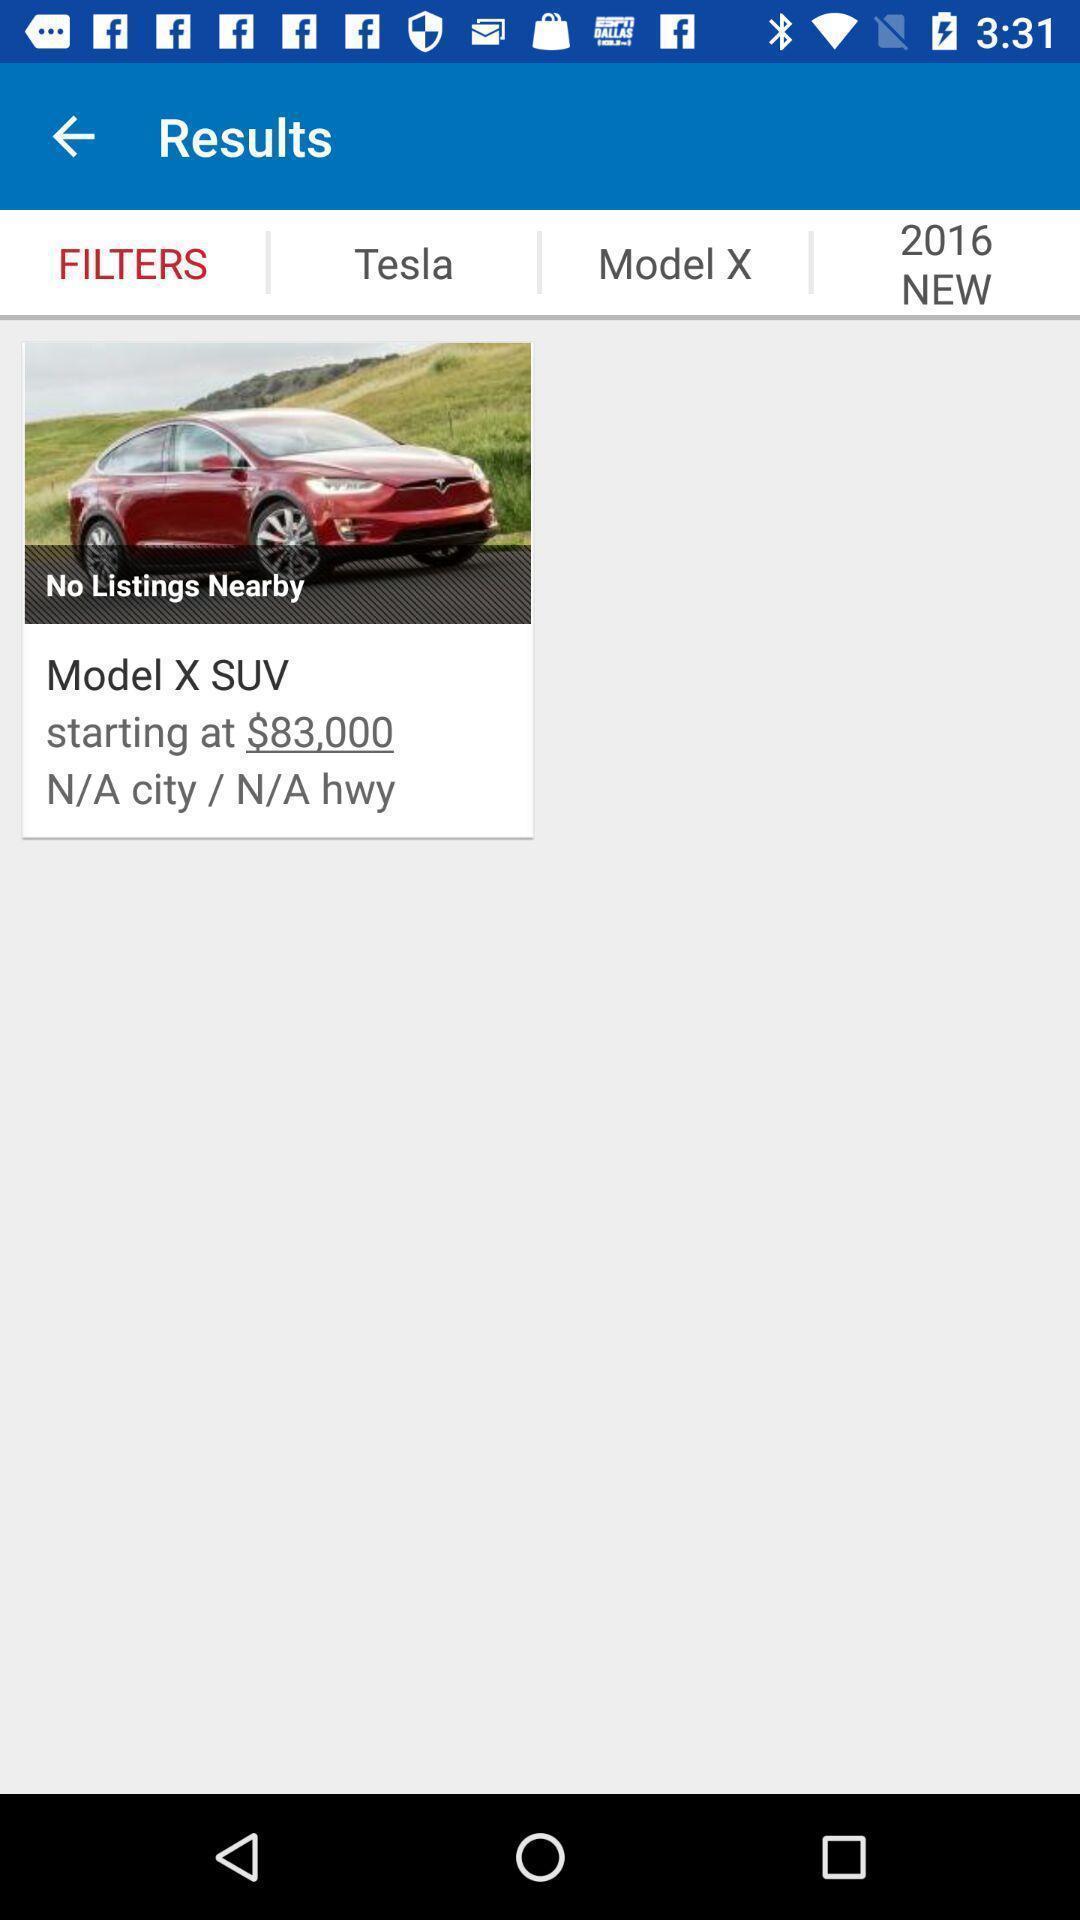Give me a narrative description of this picture. Results page with various filters displayed of a automobile app. 